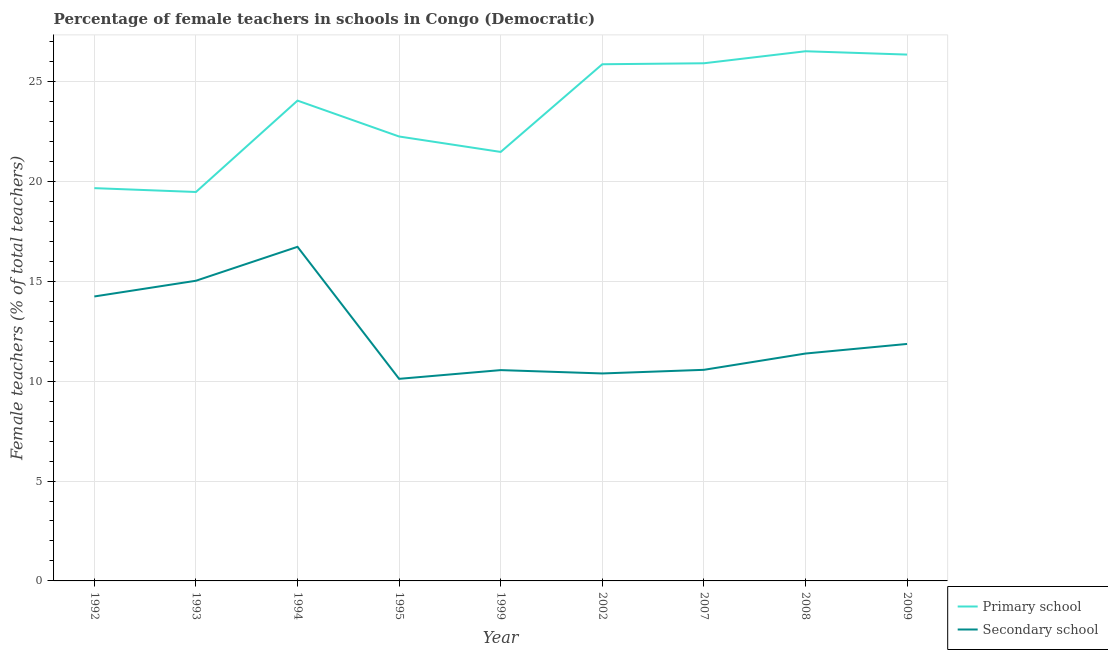Is the number of lines equal to the number of legend labels?
Offer a terse response. Yes. What is the percentage of female teachers in primary schools in 1995?
Your response must be concise. 22.24. Across all years, what is the maximum percentage of female teachers in primary schools?
Your answer should be compact. 26.51. Across all years, what is the minimum percentage of female teachers in primary schools?
Give a very brief answer. 19.47. What is the total percentage of female teachers in primary schools in the graph?
Give a very brief answer. 211.5. What is the difference between the percentage of female teachers in secondary schools in 2007 and that in 2009?
Offer a terse response. -1.3. What is the difference between the percentage of female teachers in primary schools in 2007 and the percentage of female teachers in secondary schools in 1995?
Provide a succinct answer. 15.79. What is the average percentage of female teachers in secondary schools per year?
Your answer should be compact. 12.32. In the year 1994, what is the difference between the percentage of female teachers in primary schools and percentage of female teachers in secondary schools?
Make the answer very short. 7.32. What is the ratio of the percentage of female teachers in secondary schools in 1993 to that in 2002?
Offer a very short reply. 1.45. Is the percentage of female teachers in primary schools in 2002 less than that in 2008?
Your answer should be very brief. Yes. What is the difference between the highest and the second highest percentage of female teachers in primary schools?
Your answer should be compact. 0.17. What is the difference between the highest and the lowest percentage of female teachers in secondary schools?
Your answer should be very brief. 6.61. Is the sum of the percentage of female teachers in secondary schools in 1994 and 1995 greater than the maximum percentage of female teachers in primary schools across all years?
Make the answer very short. Yes. Is the percentage of female teachers in secondary schools strictly less than the percentage of female teachers in primary schools over the years?
Provide a short and direct response. Yes. How many years are there in the graph?
Provide a succinct answer. 9. What is the difference between two consecutive major ticks on the Y-axis?
Provide a short and direct response. 5. Where does the legend appear in the graph?
Keep it short and to the point. Bottom right. How many legend labels are there?
Make the answer very short. 2. How are the legend labels stacked?
Your answer should be very brief. Vertical. What is the title of the graph?
Offer a terse response. Percentage of female teachers in schools in Congo (Democratic). Does "Food" appear as one of the legend labels in the graph?
Your answer should be very brief. No. What is the label or title of the X-axis?
Your answer should be compact. Year. What is the label or title of the Y-axis?
Ensure brevity in your answer.  Female teachers (% of total teachers). What is the Female teachers (% of total teachers) of Primary school in 1992?
Ensure brevity in your answer.  19.66. What is the Female teachers (% of total teachers) of Secondary school in 1992?
Ensure brevity in your answer.  14.24. What is the Female teachers (% of total teachers) of Primary school in 1993?
Offer a terse response. 19.47. What is the Female teachers (% of total teachers) of Secondary school in 1993?
Make the answer very short. 15.02. What is the Female teachers (% of total teachers) of Primary school in 1994?
Keep it short and to the point. 24.04. What is the Female teachers (% of total teachers) of Secondary school in 1994?
Make the answer very short. 16.72. What is the Female teachers (% of total teachers) in Primary school in 1995?
Offer a very short reply. 22.24. What is the Female teachers (% of total teachers) in Secondary school in 1995?
Your answer should be very brief. 10.11. What is the Female teachers (% of total teachers) in Primary school in 1999?
Keep it short and to the point. 21.47. What is the Female teachers (% of total teachers) of Secondary school in 1999?
Keep it short and to the point. 10.55. What is the Female teachers (% of total teachers) in Primary school in 2002?
Provide a succinct answer. 25.86. What is the Female teachers (% of total teachers) in Secondary school in 2002?
Ensure brevity in your answer.  10.38. What is the Female teachers (% of total teachers) in Primary school in 2007?
Provide a short and direct response. 25.91. What is the Female teachers (% of total teachers) in Secondary school in 2007?
Your answer should be very brief. 10.57. What is the Female teachers (% of total teachers) in Primary school in 2008?
Your answer should be very brief. 26.51. What is the Female teachers (% of total teachers) of Secondary school in 2008?
Offer a terse response. 11.38. What is the Female teachers (% of total teachers) in Primary school in 2009?
Offer a very short reply. 26.34. What is the Female teachers (% of total teachers) in Secondary school in 2009?
Your answer should be very brief. 11.86. Across all years, what is the maximum Female teachers (% of total teachers) in Primary school?
Offer a very short reply. 26.51. Across all years, what is the maximum Female teachers (% of total teachers) of Secondary school?
Provide a short and direct response. 16.72. Across all years, what is the minimum Female teachers (% of total teachers) of Primary school?
Make the answer very short. 19.47. Across all years, what is the minimum Female teachers (% of total teachers) of Secondary school?
Make the answer very short. 10.11. What is the total Female teachers (% of total teachers) of Primary school in the graph?
Your answer should be compact. 211.5. What is the total Female teachers (% of total teachers) of Secondary school in the graph?
Your answer should be very brief. 110.84. What is the difference between the Female teachers (% of total teachers) of Primary school in 1992 and that in 1993?
Offer a terse response. 0.19. What is the difference between the Female teachers (% of total teachers) in Secondary school in 1992 and that in 1993?
Give a very brief answer. -0.79. What is the difference between the Female teachers (% of total teachers) in Primary school in 1992 and that in 1994?
Ensure brevity in your answer.  -4.38. What is the difference between the Female teachers (% of total teachers) in Secondary school in 1992 and that in 1994?
Give a very brief answer. -2.48. What is the difference between the Female teachers (% of total teachers) in Primary school in 1992 and that in 1995?
Offer a terse response. -2.58. What is the difference between the Female teachers (% of total teachers) of Secondary school in 1992 and that in 1995?
Your answer should be compact. 4.12. What is the difference between the Female teachers (% of total teachers) of Primary school in 1992 and that in 1999?
Make the answer very short. -1.81. What is the difference between the Female teachers (% of total teachers) of Secondary school in 1992 and that in 1999?
Offer a very short reply. 3.69. What is the difference between the Female teachers (% of total teachers) of Primary school in 1992 and that in 2002?
Keep it short and to the point. -6.2. What is the difference between the Female teachers (% of total teachers) of Secondary school in 1992 and that in 2002?
Keep it short and to the point. 3.85. What is the difference between the Female teachers (% of total teachers) of Primary school in 1992 and that in 2007?
Your answer should be compact. -6.25. What is the difference between the Female teachers (% of total teachers) of Secondary school in 1992 and that in 2007?
Offer a terse response. 3.67. What is the difference between the Female teachers (% of total teachers) of Primary school in 1992 and that in 2008?
Provide a succinct answer. -6.85. What is the difference between the Female teachers (% of total teachers) in Secondary school in 1992 and that in 2008?
Ensure brevity in your answer.  2.86. What is the difference between the Female teachers (% of total teachers) in Primary school in 1992 and that in 2009?
Ensure brevity in your answer.  -6.68. What is the difference between the Female teachers (% of total teachers) of Secondary school in 1992 and that in 2009?
Offer a terse response. 2.38. What is the difference between the Female teachers (% of total teachers) in Primary school in 1993 and that in 1994?
Provide a succinct answer. -4.57. What is the difference between the Female teachers (% of total teachers) in Secondary school in 1993 and that in 1994?
Provide a short and direct response. -1.7. What is the difference between the Female teachers (% of total teachers) of Primary school in 1993 and that in 1995?
Provide a short and direct response. -2.78. What is the difference between the Female teachers (% of total teachers) of Secondary school in 1993 and that in 1995?
Ensure brevity in your answer.  4.91. What is the difference between the Female teachers (% of total teachers) in Primary school in 1993 and that in 1999?
Ensure brevity in your answer.  -2.01. What is the difference between the Female teachers (% of total teachers) in Secondary school in 1993 and that in 1999?
Offer a terse response. 4.47. What is the difference between the Female teachers (% of total teachers) of Primary school in 1993 and that in 2002?
Your response must be concise. -6.39. What is the difference between the Female teachers (% of total teachers) in Secondary school in 1993 and that in 2002?
Offer a very short reply. 4.64. What is the difference between the Female teachers (% of total teachers) of Primary school in 1993 and that in 2007?
Make the answer very short. -6.44. What is the difference between the Female teachers (% of total teachers) of Secondary school in 1993 and that in 2007?
Give a very brief answer. 4.46. What is the difference between the Female teachers (% of total teachers) in Primary school in 1993 and that in 2008?
Provide a succinct answer. -7.04. What is the difference between the Female teachers (% of total teachers) of Secondary school in 1993 and that in 2008?
Offer a very short reply. 3.64. What is the difference between the Female teachers (% of total teachers) in Primary school in 1993 and that in 2009?
Make the answer very short. -6.88. What is the difference between the Female teachers (% of total teachers) of Secondary school in 1993 and that in 2009?
Your answer should be compact. 3.16. What is the difference between the Female teachers (% of total teachers) of Primary school in 1994 and that in 1995?
Make the answer very short. 1.8. What is the difference between the Female teachers (% of total teachers) of Secondary school in 1994 and that in 1995?
Offer a very short reply. 6.61. What is the difference between the Female teachers (% of total teachers) of Primary school in 1994 and that in 1999?
Your response must be concise. 2.57. What is the difference between the Female teachers (% of total teachers) in Secondary school in 1994 and that in 1999?
Offer a very short reply. 6.17. What is the difference between the Female teachers (% of total teachers) in Primary school in 1994 and that in 2002?
Give a very brief answer. -1.82. What is the difference between the Female teachers (% of total teachers) of Secondary school in 1994 and that in 2002?
Your response must be concise. 6.34. What is the difference between the Female teachers (% of total teachers) in Primary school in 1994 and that in 2007?
Keep it short and to the point. -1.87. What is the difference between the Female teachers (% of total teachers) in Secondary school in 1994 and that in 2007?
Provide a succinct answer. 6.16. What is the difference between the Female teachers (% of total teachers) of Primary school in 1994 and that in 2008?
Offer a terse response. -2.47. What is the difference between the Female teachers (% of total teachers) in Secondary school in 1994 and that in 2008?
Offer a very short reply. 5.34. What is the difference between the Female teachers (% of total teachers) in Primary school in 1994 and that in 2009?
Make the answer very short. -2.3. What is the difference between the Female teachers (% of total teachers) in Secondary school in 1994 and that in 2009?
Your response must be concise. 4.86. What is the difference between the Female teachers (% of total teachers) of Primary school in 1995 and that in 1999?
Offer a very short reply. 0.77. What is the difference between the Female teachers (% of total teachers) in Secondary school in 1995 and that in 1999?
Keep it short and to the point. -0.44. What is the difference between the Female teachers (% of total teachers) in Primary school in 1995 and that in 2002?
Keep it short and to the point. -3.62. What is the difference between the Female teachers (% of total teachers) of Secondary school in 1995 and that in 2002?
Keep it short and to the point. -0.27. What is the difference between the Female teachers (% of total teachers) in Primary school in 1995 and that in 2007?
Your answer should be compact. -3.67. What is the difference between the Female teachers (% of total teachers) in Secondary school in 1995 and that in 2007?
Your answer should be very brief. -0.45. What is the difference between the Female teachers (% of total teachers) in Primary school in 1995 and that in 2008?
Ensure brevity in your answer.  -4.27. What is the difference between the Female teachers (% of total teachers) of Secondary school in 1995 and that in 2008?
Keep it short and to the point. -1.27. What is the difference between the Female teachers (% of total teachers) of Primary school in 1995 and that in 2009?
Give a very brief answer. -4.1. What is the difference between the Female teachers (% of total teachers) of Secondary school in 1995 and that in 2009?
Provide a short and direct response. -1.75. What is the difference between the Female teachers (% of total teachers) in Primary school in 1999 and that in 2002?
Your response must be concise. -4.39. What is the difference between the Female teachers (% of total teachers) in Secondary school in 1999 and that in 2002?
Provide a succinct answer. 0.17. What is the difference between the Female teachers (% of total teachers) of Primary school in 1999 and that in 2007?
Provide a short and direct response. -4.44. What is the difference between the Female teachers (% of total teachers) in Secondary school in 1999 and that in 2007?
Your answer should be very brief. -0.01. What is the difference between the Female teachers (% of total teachers) of Primary school in 1999 and that in 2008?
Offer a terse response. -5.04. What is the difference between the Female teachers (% of total teachers) of Secondary school in 1999 and that in 2008?
Offer a very short reply. -0.83. What is the difference between the Female teachers (% of total teachers) of Primary school in 1999 and that in 2009?
Your answer should be very brief. -4.87. What is the difference between the Female teachers (% of total teachers) of Secondary school in 1999 and that in 2009?
Make the answer very short. -1.31. What is the difference between the Female teachers (% of total teachers) of Primary school in 2002 and that in 2007?
Offer a very short reply. -0.05. What is the difference between the Female teachers (% of total teachers) of Secondary school in 2002 and that in 2007?
Make the answer very short. -0.18. What is the difference between the Female teachers (% of total teachers) in Primary school in 2002 and that in 2008?
Give a very brief answer. -0.65. What is the difference between the Female teachers (% of total teachers) in Secondary school in 2002 and that in 2008?
Offer a terse response. -1. What is the difference between the Female teachers (% of total teachers) of Primary school in 2002 and that in 2009?
Provide a succinct answer. -0.48. What is the difference between the Female teachers (% of total teachers) of Secondary school in 2002 and that in 2009?
Offer a terse response. -1.48. What is the difference between the Female teachers (% of total teachers) in Primary school in 2007 and that in 2008?
Provide a short and direct response. -0.6. What is the difference between the Female teachers (% of total teachers) in Secondary school in 2007 and that in 2008?
Offer a very short reply. -0.82. What is the difference between the Female teachers (% of total teachers) of Primary school in 2007 and that in 2009?
Your answer should be compact. -0.44. What is the difference between the Female teachers (% of total teachers) of Secondary school in 2007 and that in 2009?
Your response must be concise. -1.3. What is the difference between the Female teachers (% of total teachers) in Primary school in 2008 and that in 2009?
Offer a very short reply. 0.17. What is the difference between the Female teachers (% of total teachers) in Secondary school in 2008 and that in 2009?
Your answer should be very brief. -0.48. What is the difference between the Female teachers (% of total teachers) in Primary school in 1992 and the Female teachers (% of total teachers) in Secondary school in 1993?
Provide a succinct answer. 4.63. What is the difference between the Female teachers (% of total teachers) of Primary school in 1992 and the Female teachers (% of total teachers) of Secondary school in 1994?
Make the answer very short. 2.94. What is the difference between the Female teachers (% of total teachers) of Primary school in 1992 and the Female teachers (% of total teachers) of Secondary school in 1995?
Make the answer very short. 9.54. What is the difference between the Female teachers (% of total teachers) of Primary school in 1992 and the Female teachers (% of total teachers) of Secondary school in 1999?
Keep it short and to the point. 9.11. What is the difference between the Female teachers (% of total teachers) of Primary school in 1992 and the Female teachers (% of total teachers) of Secondary school in 2002?
Provide a short and direct response. 9.27. What is the difference between the Female teachers (% of total teachers) of Primary school in 1992 and the Female teachers (% of total teachers) of Secondary school in 2007?
Offer a very short reply. 9.09. What is the difference between the Female teachers (% of total teachers) of Primary school in 1992 and the Female teachers (% of total teachers) of Secondary school in 2008?
Ensure brevity in your answer.  8.28. What is the difference between the Female teachers (% of total teachers) in Primary school in 1992 and the Female teachers (% of total teachers) in Secondary school in 2009?
Your answer should be compact. 7.8. What is the difference between the Female teachers (% of total teachers) of Primary school in 1993 and the Female teachers (% of total teachers) of Secondary school in 1994?
Give a very brief answer. 2.74. What is the difference between the Female teachers (% of total teachers) of Primary school in 1993 and the Female teachers (% of total teachers) of Secondary school in 1995?
Provide a succinct answer. 9.35. What is the difference between the Female teachers (% of total teachers) in Primary school in 1993 and the Female teachers (% of total teachers) in Secondary school in 1999?
Ensure brevity in your answer.  8.91. What is the difference between the Female teachers (% of total teachers) in Primary school in 1993 and the Female teachers (% of total teachers) in Secondary school in 2002?
Provide a short and direct response. 9.08. What is the difference between the Female teachers (% of total teachers) in Primary school in 1993 and the Female teachers (% of total teachers) in Secondary school in 2007?
Make the answer very short. 8.9. What is the difference between the Female teachers (% of total teachers) of Primary school in 1993 and the Female teachers (% of total teachers) of Secondary school in 2008?
Offer a very short reply. 8.09. What is the difference between the Female teachers (% of total teachers) of Primary school in 1993 and the Female teachers (% of total teachers) of Secondary school in 2009?
Make the answer very short. 7.61. What is the difference between the Female teachers (% of total teachers) of Primary school in 1994 and the Female teachers (% of total teachers) of Secondary school in 1995?
Your answer should be very brief. 13.93. What is the difference between the Female teachers (% of total teachers) in Primary school in 1994 and the Female teachers (% of total teachers) in Secondary school in 1999?
Offer a very short reply. 13.49. What is the difference between the Female teachers (% of total teachers) of Primary school in 1994 and the Female teachers (% of total teachers) of Secondary school in 2002?
Provide a short and direct response. 13.66. What is the difference between the Female teachers (% of total teachers) in Primary school in 1994 and the Female teachers (% of total teachers) in Secondary school in 2007?
Offer a terse response. 13.47. What is the difference between the Female teachers (% of total teachers) of Primary school in 1994 and the Female teachers (% of total teachers) of Secondary school in 2008?
Provide a succinct answer. 12.66. What is the difference between the Female teachers (% of total teachers) of Primary school in 1994 and the Female teachers (% of total teachers) of Secondary school in 2009?
Offer a terse response. 12.18. What is the difference between the Female teachers (% of total teachers) of Primary school in 1995 and the Female teachers (% of total teachers) of Secondary school in 1999?
Offer a terse response. 11.69. What is the difference between the Female teachers (% of total teachers) in Primary school in 1995 and the Female teachers (% of total teachers) in Secondary school in 2002?
Your answer should be compact. 11.86. What is the difference between the Female teachers (% of total teachers) in Primary school in 1995 and the Female teachers (% of total teachers) in Secondary school in 2007?
Provide a succinct answer. 11.68. What is the difference between the Female teachers (% of total teachers) in Primary school in 1995 and the Female teachers (% of total teachers) in Secondary school in 2008?
Make the answer very short. 10.86. What is the difference between the Female teachers (% of total teachers) in Primary school in 1995 and the Female teachers (% of total teachers) in Secondary school in 2009?
Your response must be concise. 10.38. What is the difference between the Female teachers (% of total teachers) of Primary school in 1999 and the Female teachers (% of total teachers) of Secondary school in 2002?
Ensure brevity in your answer.  11.09. What is the difference between the Female teachers (% of total teachers) of Primary school in 1999 and the Female teachers (% of total teachers) of Secondary school in 2007?
Offer a terse response. 10.91. What is the difference between the Female teachers (% of total teachers) in Primary school in 1999 and the Female teachers (% of total teachers) in Secondary school in 2008?
Your answer should be very brief. 10.09. What is the difference between the Female teachers (% of total teachers) of Primary school in 1999 and the Female teachers (% of total teachers) of Secondary school in 2009?
Offer a very short reply. 9.61. What is the difference between the Female teachers (% of total teachers) in Primary school in 2002 and the Female teachers (% of total teachers) in Secondary school in 2007?
Give a very brief answer. 15.29. What is the difference between the Female teachers (% of total teachers) in Primary school in 2002 and the Female teachers (% of total teachers) in Secondary school in 2008?
Your response must be concise. 14.48. What is the difference between the Female teachers (% of total teachers) in Primary school in 2002 and the Female teachers (% of total teachers) in Secondary school in 2009?
Give a very brief answer. 14. What is the difference between the Female teachers (% of total teachers) in Primary school in 2007 and the Female teachers (% of total teachers) in Secondary school in 2008?
Give a very brief answer. 14.53. What is the difference between the Female teachers (% of total teachers) of Primary school in 2007 and the Female teachers (% of total teachers) of Secondary school in 2009?
Ensure brevity in your answer.  14.05. What is the difference between the Female teachers (% of total teachers) of Primary school in 2008 and the Female teachers (% of total teachers) of Secondary school in 2009?
Your response must be concise. 14.65. What is the average Female teachers (% of total teachers) in Primary school per year?
Give a very brief answer. 23.5. What is the average Female teachers (% of total teachers) in Secondary school per year?
Provide a succinct answer. 12.32. In the year 1992, what is the difference between the Female teachers (% of total teachers) in Primary school and Female teachers (% of total teachers) in Secondary school?
Your answer should be compact. 5.42. In the year 1993, what is the difference between the Female teachers (% of total teachers) of Primary school and Female teachers (% of total teachers) of Secondary school?
Make the answer very short. 4.44. In the year 1994, what is the difference between the Female teachers (% of total teachers) in Primary school and Female teachers (% of total teachers) in Secondary school?
Your answer should be compact. 7.32. In the year 1995, what is the difference between the Female teachers (% of total teachers) of Primary school and Female teachers (% of total teachers) of Secondary school?
Give a very brief answer. 12.13. In the year 1999, what is the difference between the Female teachers (% of total teachers) in Primary school and Female teachers (% of total teachers) in Secondary school?
Provide a short and direct response. 10.92. In the year 2002, what is the difference between the Female teachers (% of total teachers) of Primary school and Female teachers (% of total teachers) of Secondary school?
Ensure brevity in your answer.  15.48. In the year 2007, what is the difference between the Female teachers (% of total teachers) of Primary school and Female teachers (% of total teachers) of Secondary school?
Your response must be concise. 15.34. In the year 2008, what is the difference between the Female teachers (% of total teachers) of Primary school and Female teachers (% of total teachers) of Secondary school?
Provide a succinct answer. 15.13. In the year 2009, what is the difference between the Female teachers (% of total teachers) of Primary school and Female teachers (% of total teachers) of Secondary school?
Provide a succinct answer. 14.48. What is the ratio of the Female teachers (% of total teachers) in Primary school in 1992 to that in 1993?
Provide a short and direct response. 1.01. What is the ratio of the Female teachers (% of total teachers) of Secondary school in 1992 to that in 1993?
Offer a terse response. 0.95. What is the ratio of the Female teachers (% of total teachers) in Primary school in 1992 to that in 1994?
Your answer should be very brief. 0.82. What is the ratio of the Female teachers (% of total teachers) of Secondary school in 1992 to that in 1994?
Give a very brief answer. 0.85. What is the ratio of the Female teachers (% of total teachers) of Primary school in 1992 to that in 1995?
Your answer should be very brief. 0.88. What is the ratio of the Female teachers (% of total teachers) of Secondary school in 1992 to that in 1995?
Your response must be concise. 1.41. What is the ratio of the Female teachers (% of total teachers) of Primary school in 1992 to that in 1999?
Offer a very short reply. 0.92. What is the ratio of the Female teachers (% of total teachers) in Secondary school in 1992 to that in 1999?
Make the answer very short. 1.35. What is the ratio of the Female teachers (% of total teachers) of Primary school in 1992 to that in 2002?
Ensure brevity in your answer.  0.76. What is the ratio of the Female teachers (% of total teachers) in Secondary school in 1992 to that in 2002?
Your answer should be compact. 1.37. What is the ratio of the Female teachers (% of total teachers) in Primary school in 1992 to that in 2007?
Ensure brevity in your answer.  0.76. What is the ratio of the Female teachers (% of total teachers) of Secondary school in 1992 to that in 2007?
Offer a very short reply. 1.35. What is the ratio of the Female teachers (% of total teachers) in Primary school in 1992 to that in 2008?
Your answer should be compact. 0.74. What is the ratio of the Female teachers (% of total teachers) in Secondary school in 1992 to that in 2008?
Your answer should be very brief. 1.25. What is the ratio of the Female teachers (% of total teachers) of Primary school in 1992 to that in 2009?
Make the answer very short. 0.75. What is the ratio of the Female teachers (% of total teachers) of Secondary school in 1992 to that in 2009?
Provide a short and direct response. 1.2. What is the ratio of the Female teachers (% of total teachers) of Primary school in 1993 to that in 1994?
Your answer should be very brief. 0.81. What is the ratio of the Female teachers (% of total teachers) of Secondary school in 1993 to that in 1994?
Provide a short and direct response. 0.9. What is the ratio of the Female teachers (% of total teachers) in Primary school in 1993 to that in 1995?
Provide a succinct answer. 0.88. What is the ratio of the Female teachers (% of total teachers) in Secondary school in 1993 to that in 1995?
Provide a short and direct response. 1.49. What is the ratio of the Female teachers (% of total teachers) in Primary school in 1993 to that in 1999?
Your answer should be very brief. 0.91. What is the ratio of the Female teachers (% of total teachers) in Secondary school in 1993 to that in 1999?
Offer a terse response. 1.42. What is the ratio of the Female teachers (% of total teachers) of Primary school in 1993 to that in 2002?
Ensure brevity in your answer.  0.75. What is the ratio of the Female teachers (% of total teachers) of Secondary school in 1993 to that in 2002?
Give a very brief answer. 1.45. What is the ratio of the Female teachers (% of total teachers) in Primary school in 1993 to that in 2007?
Make the answer very short. 0.75. What is the ratio of the Female teachers (% of total teachers) in Secondary school in 1993 to that in 2007?
Keep it short and to the point. 1.42. What is the ratio of the Female teachers (% of total teachers) in Primary school in 1993 to that in 2008?
Provide a succinct answer. 0.73. What is the ratio of the Female teachers (% of total teachers) of Secondary school in 1993 to that in 2008?
Provide a short and direct response. 1.32. What is the ratio of the Female teachers (% of total teachers) in Primary school in 1993 to that in 2009?
Your answer should be compact. 0.74. What is the ratio of the Female teachers (% of total teachers) in Secondary school in 1993 to that in 2009?
Your response must be concise. 1.27. What is the ratio of the Female teachers (% of total teachers) of Primary school in 1994 to that in 1995?
Offer a terse response. 1.08. What is the ratio of the Female teachers (% of total teachers) of Secondary school in 1994 to that in 1995?
Give a very brief answer. 1.65. What is the ratio of the Female teachers (% of total teachers) in Primary school in 1994 to that in 1999?
Your response must be concise. 1.12. What is the ratio of the Female teachers (% of total teachers) in Secondary school in 1994 to that in 1999?
Your answer should be very brief. 1.58. What is the ratio of the Female teachers (% of total teachers) in Primary school in 1994 to that in 2002?
Provide a succinct answer. 0.93. What is the ratio of the Female teachers (% of total teachers) in Secondary school in 1994 to that in 2002?
Provide a succinct answer. 1.61. What is the ratio of the Female teachers (% of total teachers) of Primary school in 1994 to that in 2007?
Offer a terse response. 0.93. What is the ratio of the Female teachers (% of total teachers) in Secondary school in 1994 to that in 2007?
Offer a very short reply. 1.58. What is the ratio of the Female teachers (% of total teachers) in Primary school in 1994 to that in 2008?
Provide a short and direct response. 0.91. What is the ratio of the Female teachers (% of total teachers) in Secondary school in 1994 to that in 2008?
Your answer should be compact. 1.47. What is the ratio of the Female teachers (% of total teachers) in Primary school in 1994 to that in 2009?
Your answer should be compact. 0.91. What is the ratio of the Female teachers (% of total teachers) of Secondary school in 1994 to that in 2009?
Offer a very short reply. 1.41. What is the ratio of the Female teachers (% of total teachers) of Primary school in 1995 to that in 1999?
Offer a terse response. 1.04. What is the ratio of the Female teachers (% of total teachers) in Secondary school in 1995 to that in 1999?
Give a very brief answer. 0.96. What is the ratio of the Female teachers (% of total teachers) of Primary school in 1995 to that in 2002?
Provide a succinct answer. 0.86. What is the ratio of the Female teachers (% of total teachers) of Secondary school in 1995 to that in 2002?
Your answer should be very brief. 0.97. What is the ratio of the Female teachers (% of total teachers) of Primary school in 1995 to that in 2007?
Offer a very short reply. 0.86. What is the ratio of the Female teachers (% of total teachers) in Secondary school in 1995 to that in 2007?
Offer a very short reply. 0.96. What is the ratio of the Female teachers (% of total teachers) of Primary school in 1995 to that in 2008?
Your answer should be compact. 0.84. What is the ratio of the Female teachers (% of total teachers) in Secondary school in 1995 to that in 2008?
Your response must be concise. 0.89. What is the ratio of the Female teachers (% of total teachers) in Primary school in 1995 to that in 2009?
Provide a short and direct response. 0.84. What is the ratio of the Female teachers (% of total teachers) of Secondary school in 1995 to that in 2009?
Your answer should be very brief. 0.85. What is the ratio of the Female teachers (% of total teachers) in Primary school in 1999 to that in 2002?
Provide a succinct answer. 0.83. What is the ratio of the Female teachers (% of total teachers) in Secondary school in 1999 to that in 2002?
Provide a short and direct response. 1.02. What is the ratio of the Female teachers (% of total teachers) of Primary school in 1999 to that in 2007?
Provide a succinct answer. 0.83. What is the ratio of the Female teachers (% of total teachers) in Primary school in 1999 to that in 2008?
Your answer should be very brief. 0.81. What is the ratio of the Female teachers (% of total teachers) of Secondary school in 1999 to that in 2008?
Provide a short and direct response. 0.93. What is the ratio of the Female teachers (% of total teachers) of Primary school in 1999 to that in 2009?
Make the answer very short. 0.81. What is the ratio of the Female teachers (% of total teachers) of Secondary school in 1999 to that in 2009?
Offer a terse response. 0.89. What is the ratio of the Female teachers (% of total teachers) in Primary school in 2002 to that in 2007?
Provide a short and direct response. 1. What is the ratio of the Female teachers (% of total teachers) in Secondary school in 2002 to that in 2007?
Keep it short and to the point. 0.98. What is the ratio of the Female teachers (% of total teachers) of Primary school in 2002 to that in 2008?
Give a very brief answer. 0.98. What is the ratio of the Female teachers (% of total teachers) of Secondary school in 2002 to that in 2008?
Keep it short and to the point. 0.91. What is the ratio of the Female teachers (% of total teachers) of Primary school in 2002 to that in 2009?
Keep it short and to the point. 0.98. What is the ratio of the Female teachers (% of total teachers) in Secondary school in 2002 to that in 2009?
Offer a terse response. 0.88. What is the ratio of the Female teachers (% of total teachers) of Primary school in 2007 to that in 2008?
Provide a succinct answer. 0.98. What is the ratio of the Female teachers (% of total teachers) of Secondary school in 2007 to that in 2008?
Your response must be concise. 0.93. What is the ratio of the Female teachers (% of total teachers) in Primary school in 2007 to that in 2009?
Keep it short and to the point. 0.98. What is the ratio of the Female teachers (% of total teachers) of Secondary school in 2007 to that in 2009?
Provide a succinct answer. 0.89. What is the ratio of the Female teachers (% of total teachers) of Secondary school in 2008 to that in 2009?
Provide a succinct answer. 0.96. What is the difference between the highest and the second highest Female teachers (% of total teachers) of Primary school?
Offer a very short reply. 0.17. What is the difference between the highest and the second highest Female teachers (% of total teachers) of Secondary school?
Offer a terse response. 1.7. What is the difference between the highest and the lowest Female teachers (% of total teachers) in Primary school?
Offer a terse response. 7.04. What is the difference between the highest and the lowest Female teachers (% of total teachers) in Secondary school?
Your answer should be compact. 6.61. 